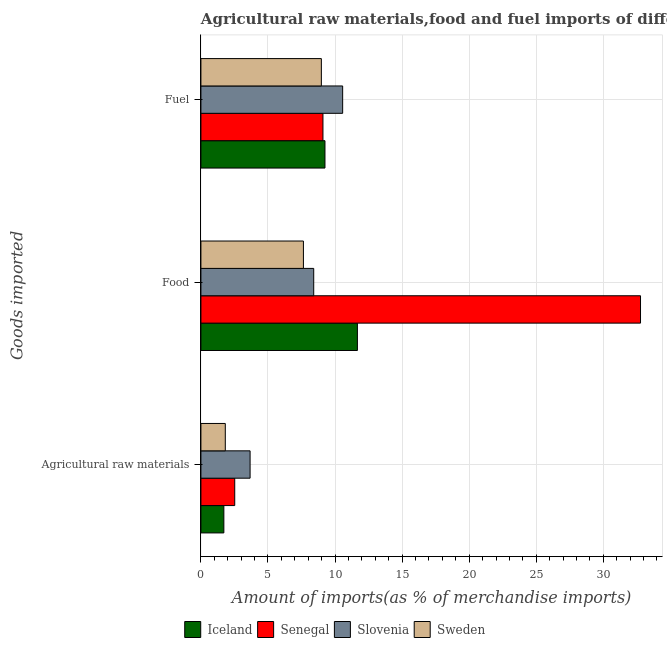How many groups of bars are there?
Make the answer very short. 3. Are the number of bars per tick equal to the number of legend labels?
Your answer should be very brief. Yes. What is the label of the 1st group of bars from the top?
Provide a short and direct response. Fuel. What is the percentage of raw materials imports in Sweden?
Ensure brevity in your answer.  1.82. Across all countries, what is the maximum percentage of fuel imports?
Provide a succinct answer. 10.57. Across all countries, what is the minimum percentage of fuel imports?
Offer a terse response. 8.98. In which country was the percentage of raw materials imports maximum?
Provide a succinct answer. Slovenia. What is the total percentage of fuel imports in the graph?
Your response must be concise. 37.89. What is the difference between the percentage of fuel imports in Sweden and that in Iceland?
Provide a succinct answer. -0.27. What is the difference between the percentage of fuel imports in Slovenia and the percentage of food imports in Sweden?
Ensure brevity in your answer.  2.93. What is the average percentage of food imports per country?
Your answer should be compact. 15.12. What is the difference between the percentage of raw materials imports and percentage of fuel imports in Slovenia?
Keep it short and to the point. -6.9. What is the ratio of the percentage of fuel imports in Iceland to that in Senegal?
Give a very brief answer. 1.02. Is the difference between the percentage of raw materials imports in Slovenia and Iceland greater than the difference between the percentage of fuel imports in Slovenia and Iceland?
Your answer should be compact. Yes. What is the difference between the highest and the second highest percentage of fuel imports?
Provide a succinct answer. 1.32. What is the difference between the highest and the lowest percentage of food imports?
Ensure brevity in your answer.  25.13. In how many countries, is the percentage of raw materials imports greater than the average percentage of raw materials imports taken over all countries?
Your answer should be compact. 2. What does the 4th bar from the top in Fuel represents?
Your response must be concise. Iceland. Is it the case that in every country, the sum of the percentage of raw materials imports and percentage of food imports is greater than the percentage of fuel imports?
Offer a terse response. Yes. How many bars are there?
Ensure brevity in your answer.  12. How many countries are there in the graph?
Your answer should be very brief. 4. What is the difference between two consecutive major ticks on the X-axis?
Give a very brief answer. 5. Does the graph contain any zero values?
Your answer should be very brief. No. Does the graph contain grids?
Your answer should be very brief. Yes. Where does the legend appear in the graph?
Keep it short and to the point. Bottom center. How are the legend labels stacked?
Your response must be concise. Horizontal. What is the title of the graph?
Give a very brief answer. Agricultural raw materials,food and fuel imports of different countries in 1993. What is the label or title of the X-axis?
Make the answer very short. Amount of imports(as % of merchandise imports). What is the label or title of the Y-axis?
Keep it short and to the point. Goods imported. What is the Amount of imports(as % of merchandise imports) of Iceland in Agricultural raw materials?
Your answer should be very brief. 1.71. What is the Amount of imports(as % of merchandise imports) in Senegal in Agricultural raw materials?
Keep it short and to the point. 2.52. What is the Amount of imports(as % of merchandise imports) of Slovenia in Agricultural raw materials?
Make the answer very short. 3.67. What is the Amount of imports(as % of merchandise imports) of Sweden in Agricultural raw materials?
Offer a terse response. 1.82. What is the Amount of imports(as % of merchandise imports) in Iceland in Food?
Provide a short and direct response. 11.67. What is the Amount of imports(as % of merchandise imports) in Senegal in Food?
Keep it short and to the point. 32.77. What is the Amount of imports(as % of merchandise imports) of Slovenia in Food?
Your answer should be very brief. 8.41. What is the Amount of imports(as % of merchandise imports) in Sweden in Food?
Keep it short and to the point. 7.64. What is the Amount of imports(as % of merchandise imports) of Iceland in Fuel?
Provide a short and direct response. 9.25. What is the Amount of imports(as % of merchandise imports) of Senegal in Fuel?
Your answer should be compact. 9.1. What is the Amount of imports(as % of merchandise imports) of Slovenia in Fuel?
Provide a succinct answer. 10.57. What is the Amount of imports(as % of merchandise imports) of Sweden in Fuel?
Make the answer very short. 8.98. Across all Goods imported, what is the maximum Amount of imports(as % of merchandise imports) in Iceland?
Offer a very short reply. 11.67. Across all Goods imported, what is the maximum Amount of imports(as % of merchandise imports) of Senegal?
Offer a terse response. 32.77. Across all Goods imported, what is the maximum Amount of imports(as % of merchandise imports) of Slovenia?
Your answer should be very brief. 10.57. Across all Goods imported, what is the maximum Amount of imports(as % of merchandise imports) in Sweden?
Your answer should be very brief. 8.98. Across all Goods imported, what is the minimum Amount of imports(as % of merchandise imports) in Iceland?
Your answer should be very brief. 1.71. Across all Goods imported, what is the minimum Amount of imports(as % of merchandise imports) in Senegal?
Give a very brief answer. 2.52. Across all Goods imported, what is the minimum Amount of imports(as % of merchandise imports) in Slovenia?
Ensure brevity in your answer.  3.67. Across all Goods imported, what is the minimum Amount of imports(as % of merchandise imports) in Sweden?
Provide a succinct answer. 1.82. What is the total Amount of imports(as % of merchandise imports) of Iceland in the graph?
Keep it short and to the point. 22.62. What is the total Amount of imports(as % of merchandise imports) in Senegal in the graph?
Your response must be concise. 44.39. What is the total Amount of imports(as % of merchandise imports) in Slovenia in the graph?
Make the answer very short. 22.64. What is the total Amount of imports(as % of merchandise imports) of Sweden in the graph?
Give a very brief answer. 18.44. What is the difference between the Amount of imports(as % of merchandise imports) of Iceland in Agricultural raw materials and that in Food?
Offer a very short reply. -9.96. What is the difference between the Amount of imports(as % of merchandise imports) of Senegal in Agricultural raw materials and that in Food?
Ensure brevity in your answer.  -30.25. What is the difference between the Amount of imports(as % of merchandise imports) in Slovenia in Agricultural raw materials and that in Food?
Make the answer very short. -4.74. What is the difference between the Amount of imports(as % of merchandise imports) of Sweden in Agricultural raw materials and that in Food?
Keep it short and to the point. -5.82. What is the difference between the Amount of imports(as % of merchandise imports) in Iceland in Agricultural raw materials and that in Fuel?
Offer a very short reply. -7.54. What is the difference between the Amount of imports(as % of merchandise imports) of Senegal in Agricultural raw materials and that in Fuel?
Offer a very short reply. -6.58. What is the difference between the Amount of imports(as % of merchandise imports) in Slovenia in Agricultural raw materials and that in Fuel?
Provide a succinct answer. -6.9. What is the difference between the Amount of imports(as % of merchandise imports) in Sweden in Agricultural raw materials and that in Fuel?
Your answer should be compact. -7.16. What is the difference between the Amount of imports(as % of merchandise imports) of Iceland in Food and that in Fuel?
Provide a succinct answer. 2.42. What is the difference between the Amount of imports(as % of merchandise imports) of Senegal in Food and that in Fuel?
Provide a succinct answer. 23.67. What is the difference between the Amount of imports(as % of merchandise imports) in Slovenia in Food and that in Fuel?
Your answer should be very brief. -2.16. What is the difference between the Amount of imports(as % of merchandise imports) of Sweden in Food and that in Fuel?
Your answer should be compact. -1.34. What is the difference between the Amount of imports(as % of merchandise imports) in Iceland in Agricultural raw materials and the Amount of imports(as % of merchandise imports) in Senegal in Food?
Make the answer very short. -31.06. What is the difference between the Amount of imports(as % of merchandise imports) of Iceland in Agricultural raw materials and the Amount of imports(as % of merchandise imports) of Slovenia in Food?
Your answer should be very brief. -6.7. What is the difference between the Amount of imports(as % of merchandise imports) of Iceland in Agricultural raw materials and the Amount of imports(as % of merchandise imports) of Sweden in Food?
Make the answer very short. -5.93. What is the difference between the Amount of imports(as % of merchandise imports) of Senegal in Agricultural raw materials and the Amount of imports(as % of merchandise imports) of Slovenia in Food?
Give a very brief answer. -5.89. What is the difference between the Amount of imports(as % of merchandise imports) of Senegal in Agricultural raw materials and the Amount of imports(as % of merchandise imports) of Sweden in Food?
Give a very brief answer. -5.12. What is the difference between the Amount of imports(as % of merchandise imports) of Slovenia in Agricultural raw materials and the Amount of imports(as % of merchandise imports) of Sweden in Food?
Ensure brevity in your answer.  -3.98. What is the difference between the Amount of imports(as % of merchandise imports) of Iceland in Agricultural raw materials and the Amount of imports(as % of merchandise imports) of Senegal in Fuel?
Offer a very short reply. -7.39. What is the difference between the Amount of imports(as % of merchandise imports) in Iceland in Agricultural raw materials and the Amount of imports(as % of merchandise imports) in Slovenia in Fuel?
Your answer should be very brief. -8.86. What is the difference between the Amount of imports(as % of merchandise imports) in Iceland in Agricultural raw materials and the Amount of imports(as % of merchandise imports) in Sweden in Fuel?
Your answer should be compact. -7.27. What is the difference between the Amount of imports(as % of merchandise imports) in Senegal in Agricultural raw materials and the Amount of imports(as % of merchandise imports) in Slovenia in Fuel?
Make the answer very short. -8.05. What is the difference between the Amount of imports(as % of merchandise imports) in Senegal in Agricultural raw materials and the Amount of imports(as % of merchandise imports) in Sweden in Fuel?
Ensure brevity in your answer.  -6.46. What is the difference between the Amount of imports(as % of merchandise imports) of Slovenia in Agricultural raw materials and the Amount of imports(as % of merchandise imports) of Sweden in Fuel?
Your answer should be compact. -5.31. What is the difference between the Amount of imports(as % of merchandise imports) of Iceland in Food and the Amount of imports(as % of merchandise imports) of Senegal in Fuel?
Make the answer very short. 2.57. What is the difference between the Amount of imports(as % of merchandise imports) of Iceland in Food and the Amount of imports(as % of merchandise imports) of Slovenia in Fuel?
Offer a very short reply. 1.1. What is the difference between the Amount of imports(as % of merchandise imports) of Iceland in Food and the Amount of imports(as % of merchandise imports) of Sweden in Fuel?
Offer a very short reply. 2.69. What is the difference between the Amount of imports(as % of merchandise imports) of Senegal in Food and the Amount of imports(as % of merchandise imports) of Slovenia in Fuel?
Your answer should be compact. 22.21. What is the difference between the Amount of imports(as % of merchandise imports) in Senegal in Food and the Amount of imports(as % of merchandise imports) in Sweden in Fuel?
Offer a terse response. 23.79. What is the difference between the Amount of imports(as % of merchandise imports) in Slovenia in Food and the Amount of imports(as % of merchandise imports) in Sweden in Fuel?
Make the answer very short. -0.57. What is the average Amount of imports(as % of merchandise imports) in Iceland per Goods imported?
Your answer should be very brief. 7.54. What is the average Amount of imports(as % of merchandise imports) of Senegal per Goods imported?
Offer a terse response. 14.8. What is the average Amount of imports(as % of merchandise imports) of Slovenia per Goods imported?
Provide a short and direct response. 7.55. What is the average Amount of imports(as % of merchandise imports) of Sweden per Goods imported?
Your answer should be very brief. 6.15. What is the difference between the Amount of imports(as % of merchandise imports) in Iceland and Amount of imports(as % of merchandise imports) in Senegal in Agricultural raw materials?
Provide a short and direct response. -0.81. What is the difference between the Amount of imports(as % of merchandise imports) of Iceland and Amount of imports(as % of merchandise imports) of Slovenia in Agricultural raw materials?
Provide a short and direct response. -1.96. What is the difference between the Amount of imports(as % of merchandise imports) of Iceland and Amount of imports(as % of merchandise imports) of Sweden in Agricultural raw materials?
Provide a short and direct response. -0.11. What is the difference between the Amount of imports(as % of merchandise imports) of Senegal and Amount of imports(as % of merchandise imports) of Slovenia in Agricultural raw materials?
Make the answer very short. -1.15. What is the difference between the Amount of imports(as % of merchandise imports) of Senegal and Amount of imports(as % of merchandise imports) of Sweden in Agricultural raw materials?
Give a very brief answer. 0.7. What is the difference between the Amount of imports(as % of merchandise imports) in Slovenia and Amount of imports(as % of merchandise imports) in Sweden in Agricultural raw materials?
Provide a succinct answer. 1.85. What is the difference between the Amount of imports(as % of merchandise imports) of Iceland and Amount of imports(as % of merchandise imports) of Senegal in Food?
Your response must be concise. -21.11. What is the difference between the Amount of imports(as % of merchandise imports) of Iceland and Amount of imports(as % of merchandise imports) of Slovenia in Food?
Your response must be concise. 3.26. What is the difference between the Amount of imports(as % of merchandise imports) in Iceland and Amount of imports(as % of merchandise imports) in Sweden in Food?
Make the answer very short. 4.02. What is the difference between the Amount of imports(as % of merchandise imports) in Senegal and Amount of imports(as % of merchandise imports) in Slovenia in Food?
Make the answer very short. 24.36. What is the difference between the Amount of imports(as % of merchandise imports) in Senegal and Amount of imports(as % of merchandise imports) in Sweden in Food?
Give a very brief answer. 25.13. What is the difference between the Amount of imports(as % of merchandise imports) of Slovenia and Amount of imports(as % of merchandise imports) of Sweden in Food?
Provide a short and direct response. 0.77. What is the difference between the Amount of imports(as % of merchandise imports) in Iceland and Amount of imports(as % of merchandise imports) in Slovenia in Fuel?
Provide a succinct answer. -1.32. What is the difference between the Amount of imports(as % of merchandise imports) of Iceland and Amount of imports(as % of merchandise imports) of Sweden in Fuel?
Offer a very short reply. 0.27. What is the difference between the Amount of imports(as % of merchandise imports) of Senegal and Amount of imports(as % of merchandise imports) of Slovenia in Fuel?
Offer a very short reply. -1.47. What is the difference between the Amount of imports(as % of merchandise imports) of Senegal and Amount of imports(as % of merchandise imports) of Sweden in Fuel?
Provide a short and direct response. 0.12. What is the difference between the Amount of imports(as % of merchandise imports) in Slovenia and Amount of imports(as % of merchandise imports) in Sweden in Fuel?
Your response must be concise. 1.59. What is the ratio of the Amount of imports(as % of merchandise imports) of Iceland in Agricultural raw materials to that in Food?
Give a very brief answer. 0.15. What is the ratio of the Amount of imports(as % of merchandise imports) of Senegal in Agricultural raw materials to that in Food?
Make the answer very short. 0.08. What is the ratio of the Amount of imports(as % of merchandise imports) of Slovenia in Agricultural raw materials to that in Food?
Keep it short and to the point. 0.44. What is the ratio of the Amount of imports(as % of merchandise imports) in Sweden in Agricultural raw materials to that in Food?
Your response must be concise. 0.24. What is the ratio of the Amount of imports(as % of merchandise imports) of Iceland in Agricultural raw materials to that in Fuel?
Give a very brief answer. 0.18. What is the ratio of the Amount of imports(as % of merchandise imports) of Senegal in Agricultural raw materials to that in Fuel?
Keep it short and to the point. 0.28. What is the ratio of the Amount of imports(as % of merchandise imports) in Slovenia in Agricultural raw materials to that in Fuel?
Ensure brevity in your answer.  0.35. What is the ratio of the Amount of imports(as % of merchandise imports) of Sweden in Agricultural raw materials to that in Fuel?
Offer a very short reply. 0.2. What is the ratio of the Amount of imports(as % of merchandise imports) of Iceland in Food to that in Fuel?
Your answer should be very brief. 1.26. What is the ratio of the Amount of imports(as % of merchandise imports) of Senegal in Food to that in Fuel?
Offer a terse response. 3.6. What is the ratio of the Amount of imports(as % of merchandise imports) of Slovenia in Food to that in Fuel?
Make the answer very short. 0.8. What is the ratio of the Amount of imports(as % of merchandise imports) in Sweden in Food to that in Fuel?
Ensure brevity in your answer.  0.85. What is the difference between the highest and the second highest Amount of imports(as % of merchandise imports) of Iceland?
Give a very brief answer. 2.42. What is the difference between the highest and the second highest Amount of imports(as % of merchandise imports) of Senegal?
Make the answer very short. 23.67. What is the difference between the highest and the second highest Amount of imports(as % of merchandise imports) of Slovenia?
Offer a very short reply. 2.16. What is the difference between the highest and the second highest Amount of imports(as % of merchandise imports) in Sweden?
Give a very brief answer. 1.34. What is the difference between the highest and the lowest Amount of imports(as % of merchandise imports) of Iceland?
Make the answer very short. 9.96. What is the difference between the highest and the lowest Amount of imports(as % of merchandise imports) in Senegal?
Ensure brevity in your answer.  30.25. What is the difference between the highest and the lowest Amount of imports(as % of merchandise imports) in Slovenia?
Ensure brevity in your answer.  6.9. What is the difference between the highest and the lowest Amount of imports(as % of merchandise imports) in Sweden?
Your answer should be compact. 7.16. 